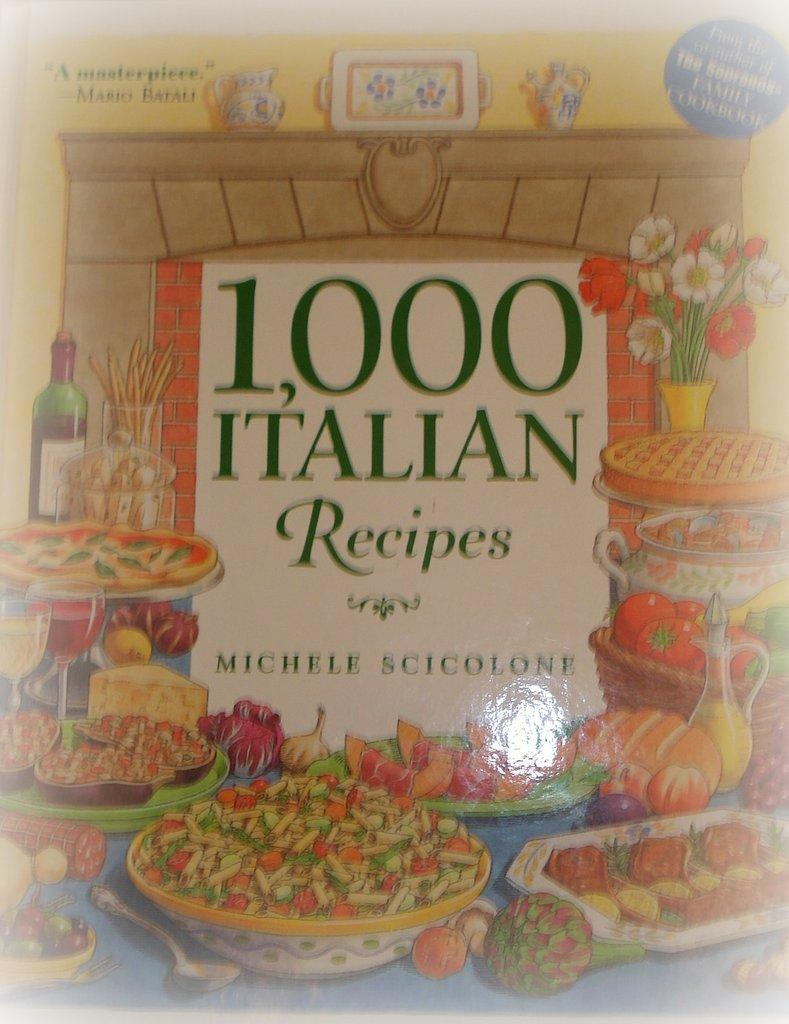<image>
Provide a brief description of the given image. A book entitled 1000 Italian recipes by a person named Michele. 